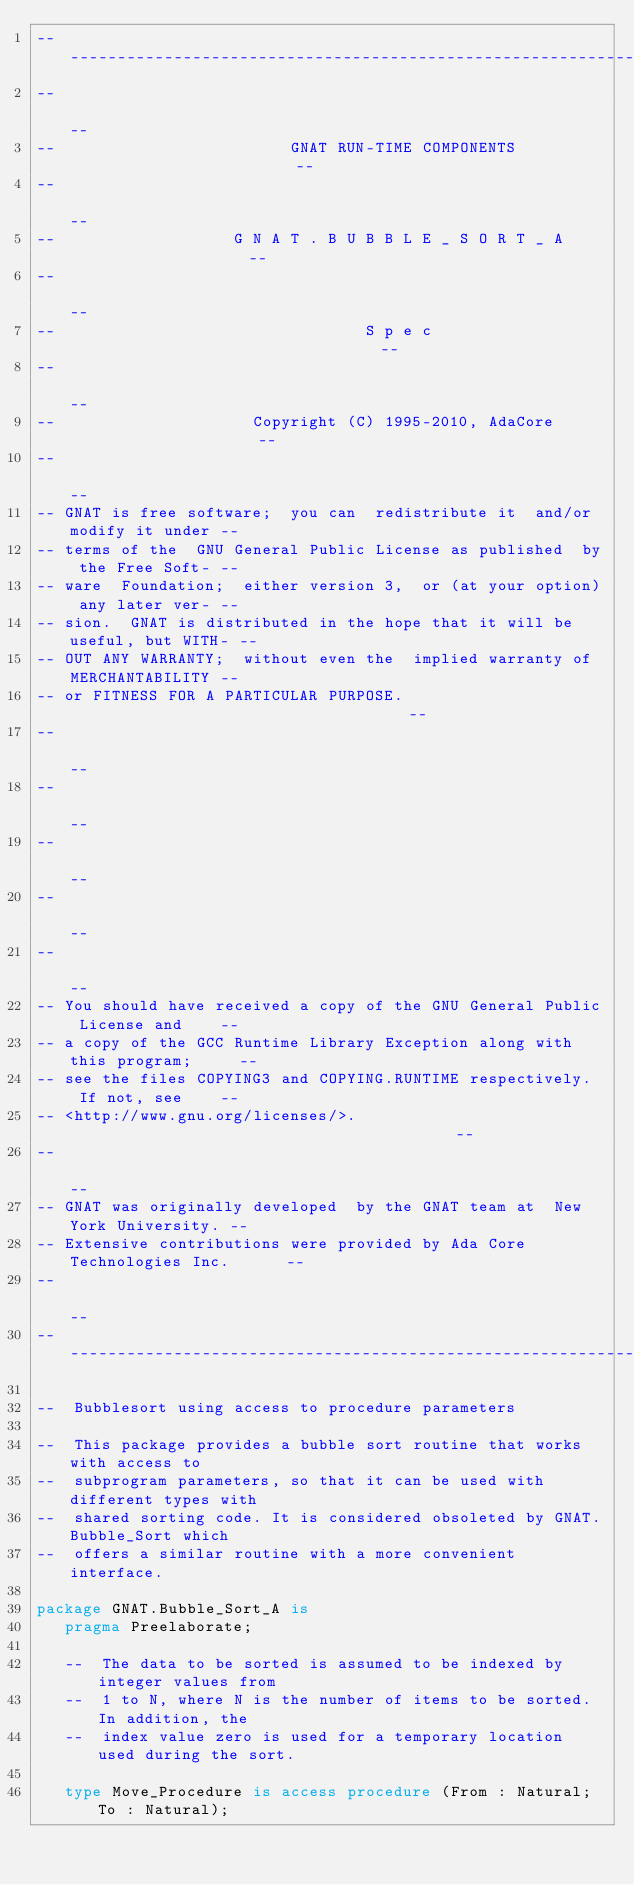Convert code to text. <code><loc_0><loc_0><loc_500><loc_500><_Ada_>------------------------------------------------------------------------------
--                                                                          --
--                         GNAT RUN-TIME COMPONENTS                         --
--                                                                          --
--                   G N A T . B U B B L E _ S O R T _ A                    --
--                                                                          --
--                                 S p e c                                  --
--                                                                          --
--                     Copyright (C) 1995-2010, AdaCore                     --
--                                                                          --
-- GNAT is free software;  you can  redistribute it  and/or modify it under --
-- terms of the  GNU General Public License as published  by the Free Soft- --
-- ware  Foundation;  either version 3,  or (at your option) any later ver- --
-- sion.  GNAT is distributed in the hope that it will be useful, but WITH- --
-- OUT ANY WARRANTY;  without even the  implied warranty of MERCHANTABILITY --
-- or FITNESS FOR A PARTICULAR PURPOSE.                                     --
--                                                                          --
--                                                                          --
--                                                                          --
--                                                                          --
--                                                                          --
-- You should have received a copy of the GNU General Public License and    --
-- a copy of the GCC Runtime Library Exception along with this program;     --
-- see the files COPYING3 and COPYING.RUNTIME respectively.  If not, see    --
-- <http://www.gnu.org/licenses/>.                                          --
--                                                                          --
-- GNAT was originally developed  by the GNAT team at  New York University. --
-- Extensive contributions were provided by Ada Core Technologies Inc.      --
--                                                                          --
------------------------------------------------------------------------------

--  Bubblesort using access to procedure parameters

--  This package provides a bubble sort routine that works with access to
--  subprogram parameters, so that it can be used with different types with
--  shared sorting code. It is considered obsoleted by GNAT.Bubble_Sort which
--  offers a similar routine with a more convenient interface.

package GNAT.Bubble_Sort_A is
   pragma Preelaborate;

   --  The data to be sorted is assumed to be indexed by integer values from
   --  1 to N, where N is the number of items to be sorted. In addition, the
   --  index value zero is used for a temporary location used during the sort.

   type Move_Procedure is access procedure (From : Natural; To : Natural);</code> 